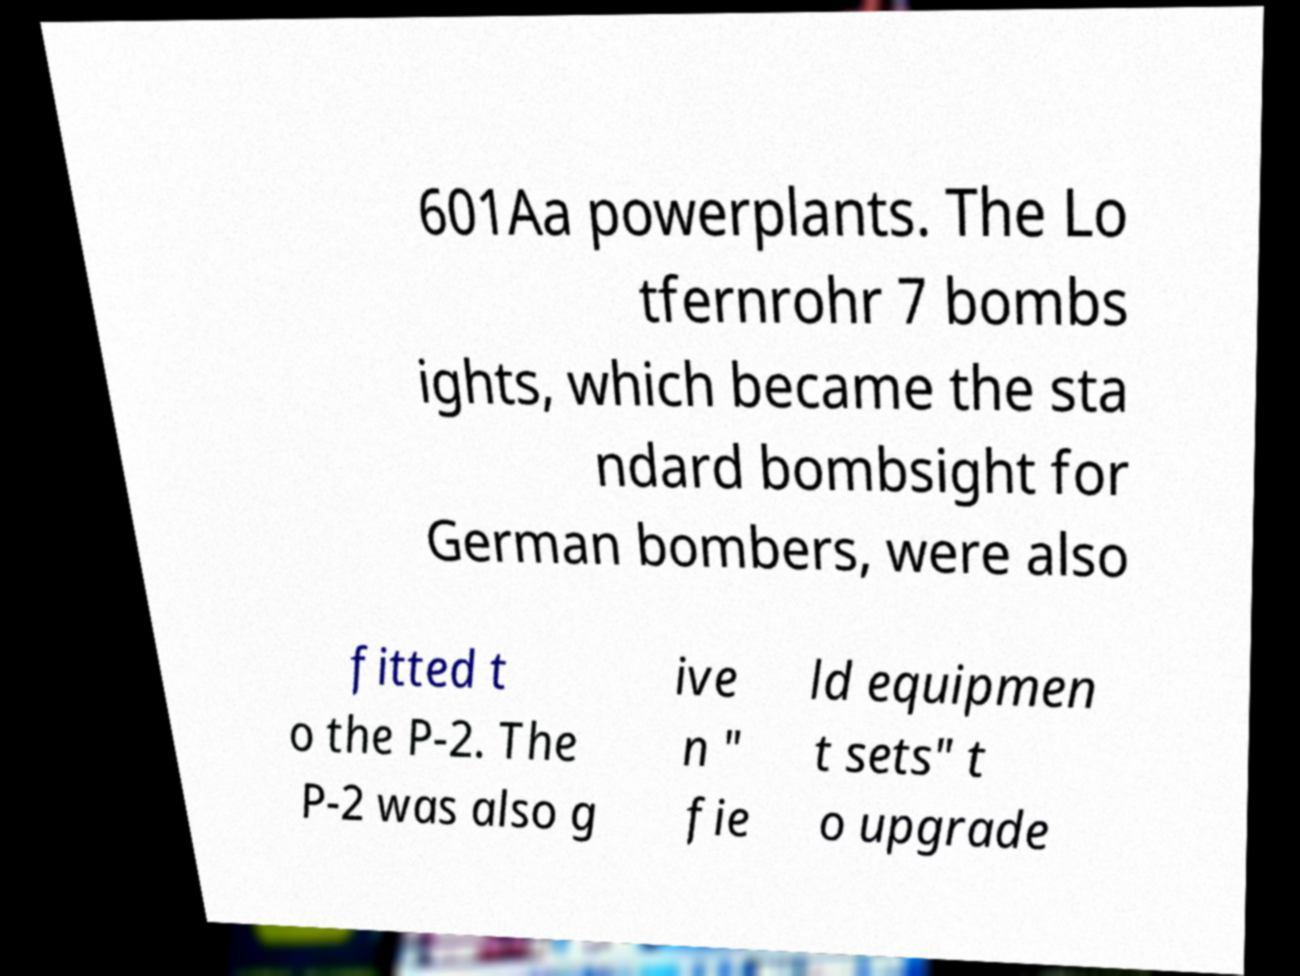For documentation purposes, I need the text within this image transcribed. Could you provide that? 601Aa powerplants. The Lo tfernrohr 7 bombs ights, which became the sta ndard bombsight for German bombers, were also fitted t o the P-2. The P-2 was also g ive n " fie ld equipmen t sets" t o upgrade 